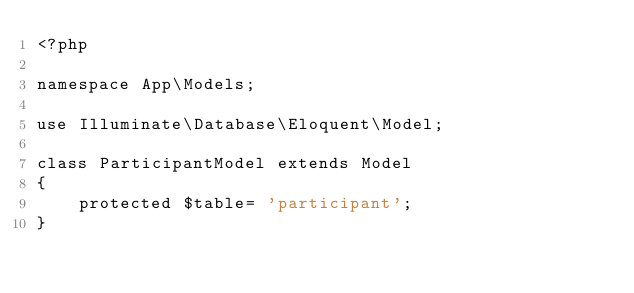<code> <loc_0><loc_0><loc_500><loc_500><_PHP_><?php

namespace App\Models;

use Illuminate\Database\Eloquent\Model;

class ParticipantModel extends Model
{
    protected $table= 'participant';
}
</code> 